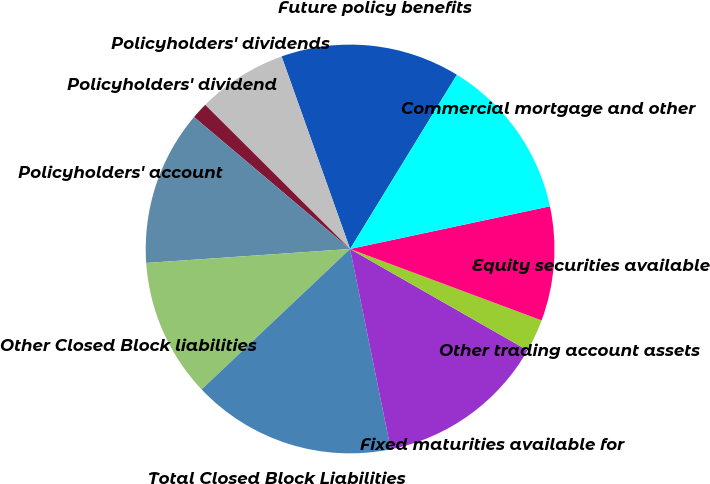<chart> <loc_0><loc_0><loc_500><loc_500><pie_chart><fcel>Future policy benefits<fcel>Policyholders' dividends<fcel>Policyholders' dividend<fcel>Policyholders' account<fcel>Other Closed Block liabilities<fcel>Total Closed Block Liabilities<fcel>Fixed maturities available for<fcel>Other trading account assets<fcel>Equity securities available<fcel>Commercial mortgage and other<nl><fcel>14.19%<fcel>7.1%<fcel>1.29%<fcel>12.26%<fcel>10.97%<fcel>16.13%<fcel>13.55%<fcel>2.58%<fcel>9.03%<fcel>12.9%<nl></chart> 